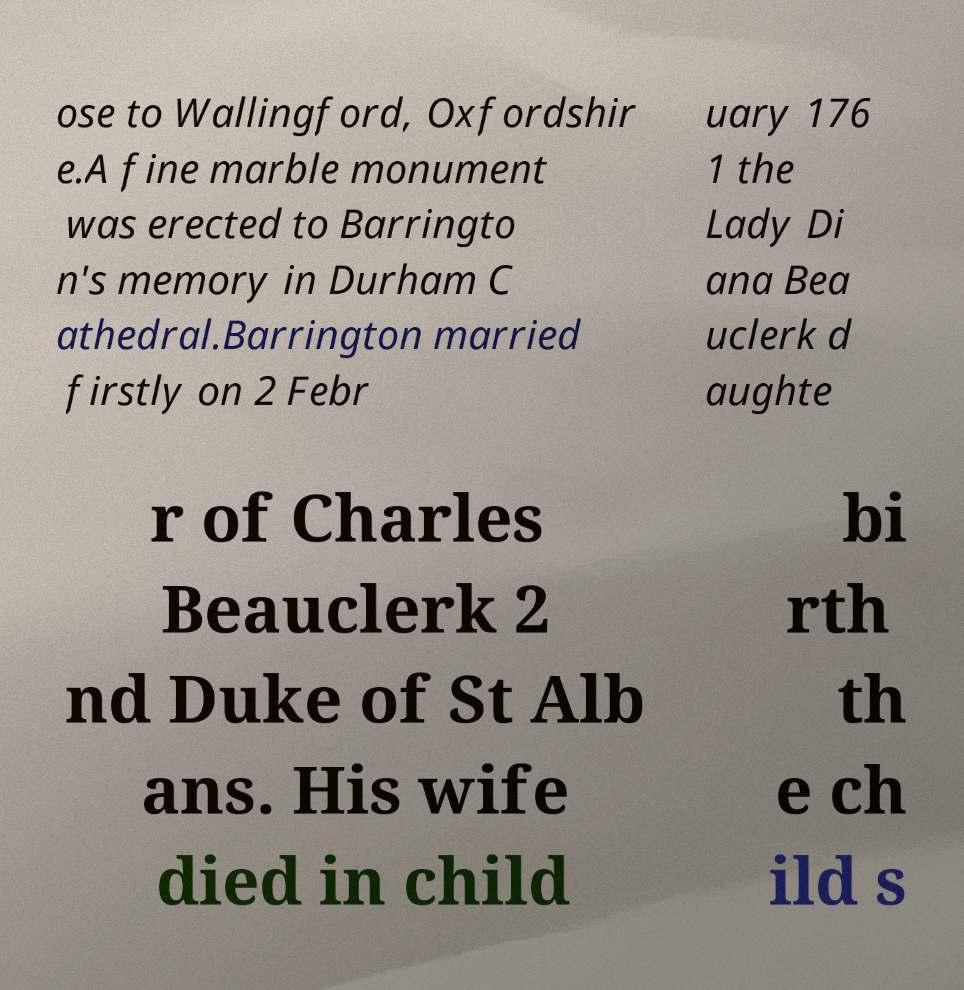Please read and relay the text visible in this image. What does it say? ose to Wallingford, Oxfordshir e.A fine marble monument was erected to Barringto n's memory in Durham C athedral.Barrington married firstly on 2 Febr uary 176 1 the Lady Di ana Bea uclerk d aughte r of Charles Beauclerk 2 nd Duke of St Alb ans. His wife died in child bi rth th e ch ild s 